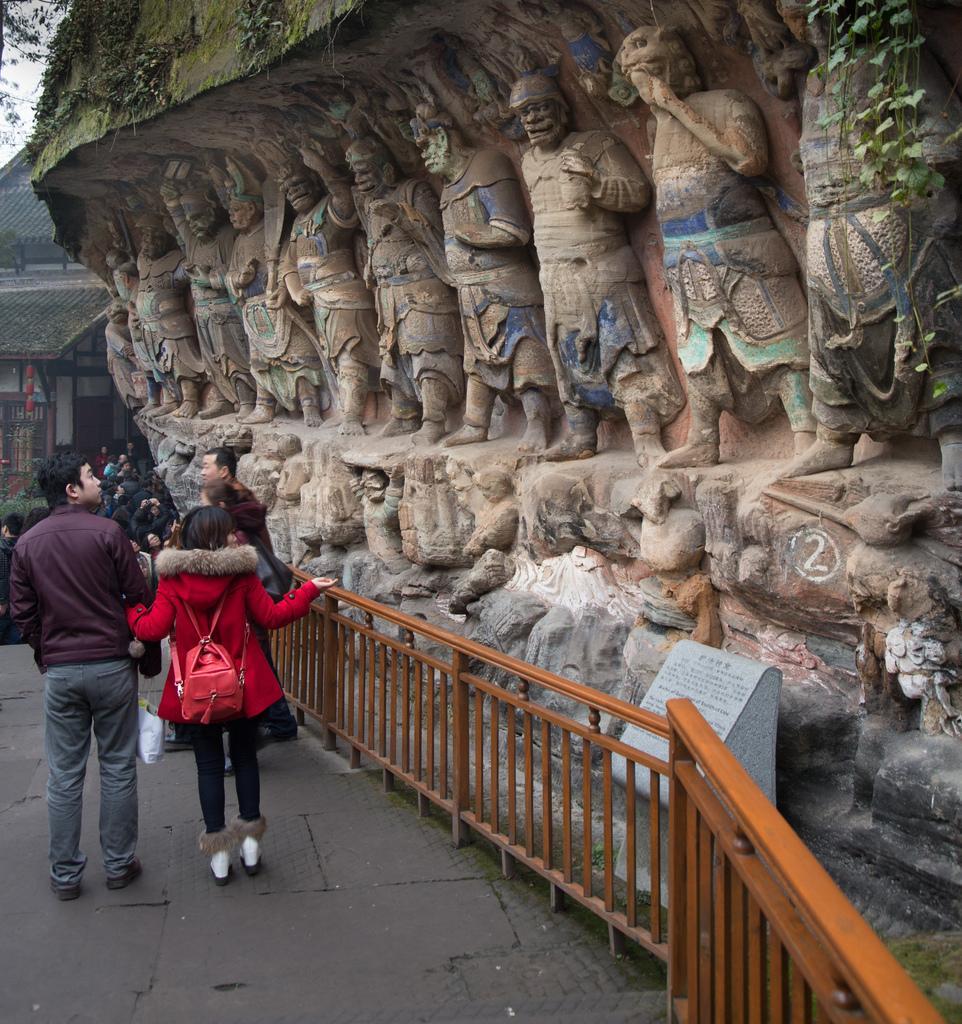Can you describe this image briefly? In this image I see number of sculptures over here and I see the path on which there are number of people and I see the railing over here. In the background I see a building and I see the leaves. 